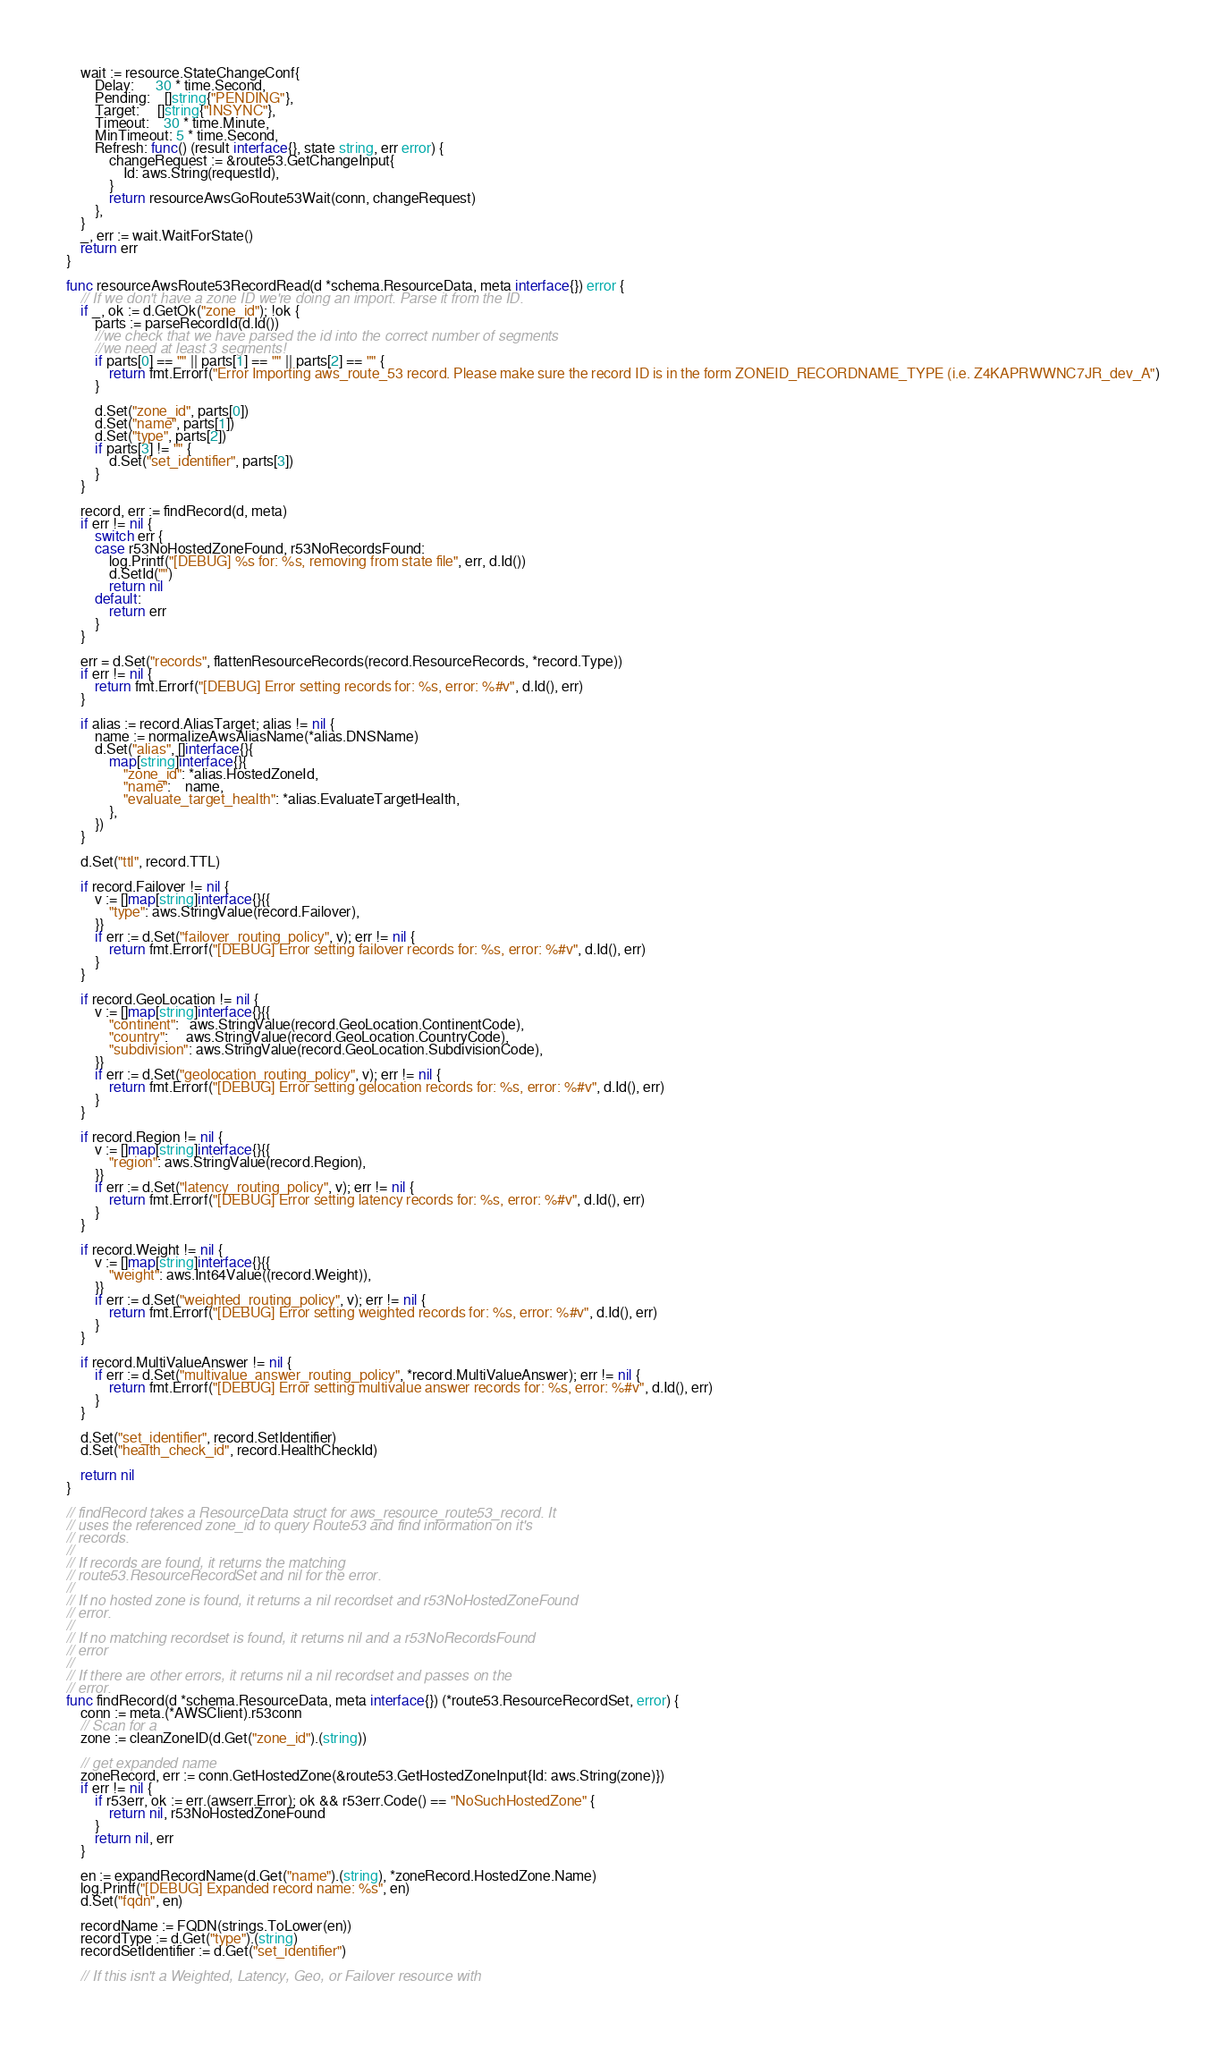Convert code to text. <code><loc_0><loc_0><loc_500><loc_500><_Go_>	wait := resource.StateChangeConf{
		Delay:      30 * time.Second,
		Pending:    []string{"PENDING"},
		Target:     []string{"INSYNC"},
		Timeout:    30 * time.Minute,
		MinTimeout: 5 * time.Second,
		Refresh: func() (result interface{}, state string, err error) {
			changeRequest := &route53.GetChangeInput{
				Id: aws.String(requestId),
			}
			return resourceAwsGoRoute53Wait(conn, changeRequest)
		},
	}
	_, err := wait.WaitForState()
	return err
}

func resourceAwsRoute53RecordRead(d *schema.ResourceData, meta interface{}) error {
	// If we don't have a zone ID we're doing an import. Parse it from the ID.
	if _, ok := d.GetOk("zone_id"); !ok {
		parts := parseRecordId(d.Id())
		//we check that we have parsed the id into the correct number of segments
		//we need at least 3 segments!
		if parts[0] == "" || parts[1] == "" || parts[2] == "" {
			return fmt.Errorf("Error Importing aws_route_53 record. Please make sure the record ID is in the form ZONEID_RECORDNAME_TYPE (i.e. Z4KAPRWWNC7JR_dev_A")
		}

		d.Set("zone_id", parts[0])
		d.Set("name", parts[1])
		d.Set("type", parts[2])
		if parts[3] != "" {
			d.Set("set_identifier", parts[3])
		}
	}

	record, err := findRecord(d, meta)
	if err != nil {
		switch err {
		case r53NoHostedZoneFound, r53NoRecordsFound:
			log.Printf("[DEBUG] %s for: %s, removing from state file", err, d.Id())
			d.SetId("")
			return nil
		default:
			return err
		}
	}

	err = d.Set("records", flattenResourceRecords(record.ResourceRecords, *record.Type))
	if err != nil {
		return fmt.Errorf("[DEBUG] Error setting records for: %s, error: %#v", d.Id(), err)
	}

	if alias := record.AliasTarget; alias != nil {
		name := normalizeAwsAliasName(*alias.DNSName)
		d.Set("alias", []interface{}{
			map[string]interface{}{
				"zone_id": *alias.HostedZoneId,
				"name":    name,
				"evaluate_target_health": *alias.EvaluateTargetHealth,
			},
		})
	}

	d.Set("ttl", record.TTL)

	if record.Failover != nil {
		v := []map[string]interface{}{{
			"type": aws.StringValue(record.Failover),
		}}
		if err := d.Set("failover_routing_policy", v); err != nil {
			return fmt.Errorf("[DEBUG] Error setting failover records for: %s, error: %#v", d.Id(), err)
		}
	}

	if record.GeoLocation != nil {
		v := []map[string]interface{}{{
			"continent":   aws.StringValue(record.GeoLocation.ContinentCode),
			"country":     aws.StringValue(record.GeoLocation.CountryCode),
			"subdivision": aws.StringValue(record.GeoLocation.SubdivisionCode),
		}}
		if err := d.Set("geolocation_routing_policy", v); err != nil {
			return fmt.Errorf("[DEBUG] Error setting gelocation records for: %s, error: %#v", d.Id(), err)
		}
	}

	if record.Region != nil {
		v := []map[string]interface{}{{
			"region": aws.StringValue(record.Region),
		}}
		if err := d.Set("latency_routing_policy", v); err != nil {
			return fmt.Errorf("[DEBUG] Error setting latency records for: %s, error: %#v", d.Id(), err)
		}
	}

	if record.Weight != nil {
		v := []map[string]interface{}{{
			"weight": aws.Int64Value((record.Weight)),
		}}
		if err := d.Set("weighted_routing_policy", v); err != nil {
			return fmt.Errorf("[DEBUG] Error setting weighted records for: %s, error: %#v", d.Id(), err)
		}
	}

	if record.MultiValueAnswer != nil {
		if err := d.Set("multivalue_answer_routing_policy", *record.MultiValueAnswer); err != nil {
			return fmt.Errorf("[DEBUG] Error setting multivalue answer records for: %s, error: %#v", d.Id(), err)
		}
	}

	d.Set("set_identifier", record.SetIdentifier)
	d.Set("health_check_id", record.HealthCheckId)

	return nil
}

// findRecord takes a ResourceData struct for aws_resource_route53_record. It
// uses the referenced zone_id to query Route53 and find information on it's
// records.
//
// If records are found, it returns the matching
// route53.ResourceRecordSet and nil for the error.
//
// If no hosted zone is found, it returns a nil recordset and r53NoHostedZoneFound
// error.
//
// If no matching recordset is found, it returns nil and a r53NoRecordsFound
// error
//
// If there are other errors, it returns nil a nil recordset and passes on the
// error.
func findRecord(d *schema.ResourceData, meta interface{}) (*route53.ResourceRecordSet, error) {
	conn := meta.(*AWSClient).r53conn
	// Scan for a
	zone := cleanZoneID(d.Get("zone_id").(string))

	// get expanded name
	zoneRecord, err := conn.GetHostedZone(&route53.GetHostedZoneInput{Id: aws.String(zone)})
	if err != nil {
		if r53err, ok := err.(awserr.Error); ok && r53err.Code() == "NoSuchHostedZone" {
			return nil, r53NoHostedZoneFound
		}
		return nil, err
	}

	en := expandRecordName(d.Get("name").(string), *zoneRecord.HostedZone.Name)
	log.Printf("[DEBUG] Expanded record name: %s", en)
	d.Set("fqdn", en)

	recordName := FQDN(strings.ToLower(en))
	recordType := d.Get("type").(string)
	recordSetIdentifier := d.Get("set_identifier")

	// If this isn't a Weighted, Latency, Geo, or Failover resource with</code> 